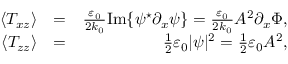Convert formula to latex. <formula><loc_0><loc_0><loc_500><loc_500>\begin{array} { r l r } { \langle T _ { x z } \rangle } & { = } & { \frac { \varepsilon _ { 0 } } { 2 k _ { 0 } } I m \{ \psi ^ { ^ { * } } \partial _ { x } \psi \} = \frac { \varepsilon _ { 0 } } { 2 k _ { 0 } } A ^ { 2 } \partial _ { x } \Phi , } \\ { \langle T _ { z z } \rangle } & { = } & { \frac { 1 } { 2 } \varepsilon _ { 0 } | \psi | ^ { 2 } = \frac { 1 } { 2 } \varepsilon _ { 0 } A ^ { 2 } , } \end{array}</formula> 